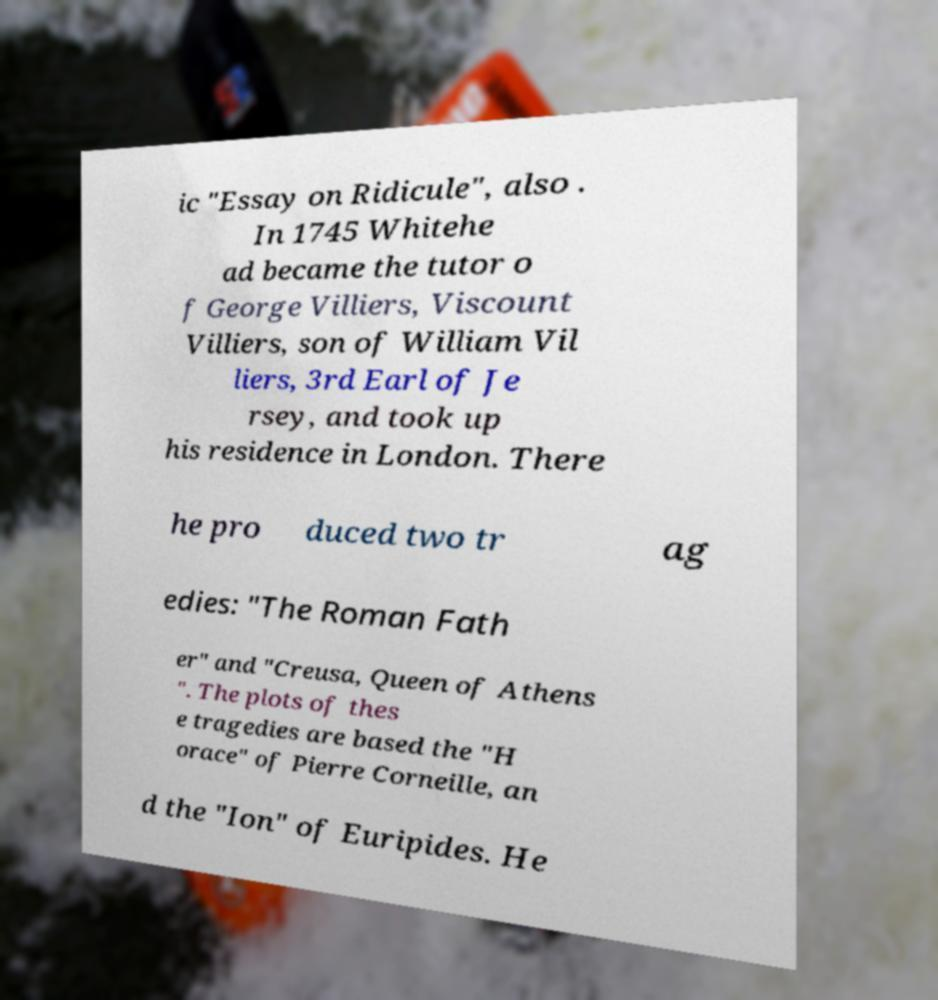There's text embedded in this image that I need extracted. Can you transcribe it verbatim? ic "Essay on Ridicule", also . In 1745 Whitehe ad became the tutor o f George Villiers, Viscount Villiers, son of William Vil liers, 3rd Earl of Je rsey, and took up his residence in London. There he pro duced two tr ag edies: "The Roman Fath er" and "Creusa, Queen of Athens ". The plots of thes e tragedies are based the "H orace" of Pierre Corneille, an d the "Ion" of Euripides. He 